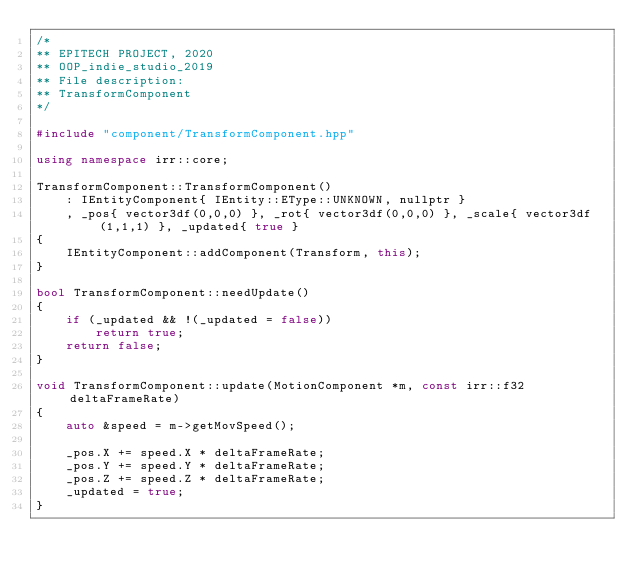Convert code to text. <code><loc_0><loc_0><loc_500><loc_500><_C++_>/*
** EPITECH PROJECT, 2020
** OOP_indie_studio_2019
** File description:
** TransformComponent
*/

#include "component/TransformComponent.hpp"

using namespace irr::core;

TransformComponent::TransformComponent()
    : IEntityComponent{ IEntity::EType::UNKNOWN, nullptr }
    , _pos{ vector3df(0,0,0) }, _rot{ vector3df(0,0,0) }, _scale{ vector3df(1,1,1) }, _updated{ true }
{
    IEntityComponent::addComponent(Transform, this);
}

bool TransformComponent::needUpdate()
{
    if (_updated && !(_updated = false))
        return true;
    return false;
}

void TransformComponent::update(MotionComponent *m, const irr::f32 deltaFrameRate)
{
    auto &speed = m->getMovSpeed();

    _pos.X += speed.X * deltaFrameRate;
    _pos.Y += speed.Y * deltaFrameRate;
    _pos.Z += speed.Z * deltaFrameRate;
    _updated = true;
}</code> 